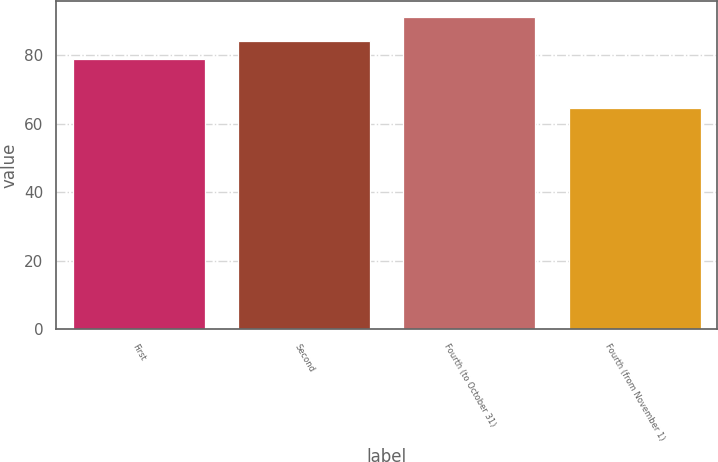Convert chart. <chart><loc_0><loc_0><loc_500><loc_500><bar_chart><fcel>First<fcel>Second<fcel>Fourth (to October 31)<fcel>Fourth (from November 1)<nl><fcel>78.79<fcel>84.19<fcel>91.25<fcel>64.74<nl></chart> 